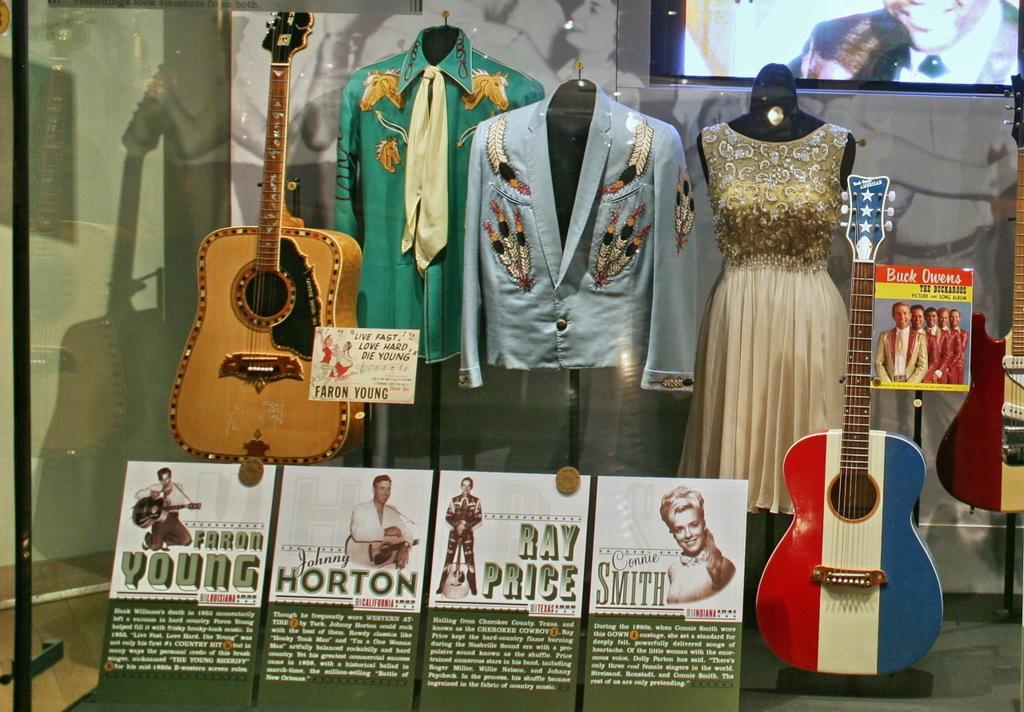Describe this image in one or two sentences. In this image I can see a glass. In side the glass there are guitars,clothes and the screen. 